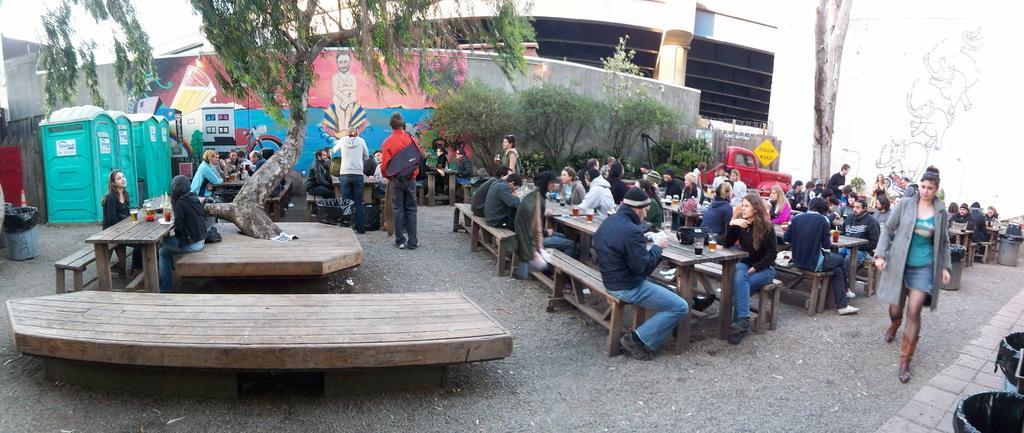Could you give a brief overview of what you see in this image? On the left side of the picture there are toilets, benches, tables, tree, dustbin, paper, drinks, wall and other food items. In the center of the picture there are people, tables, beer, food items, benches, trees and other objects. On the left there are people, tree, car, table, benches, wall and food items. On the left there are two dustbins. In the background there is a construction. 